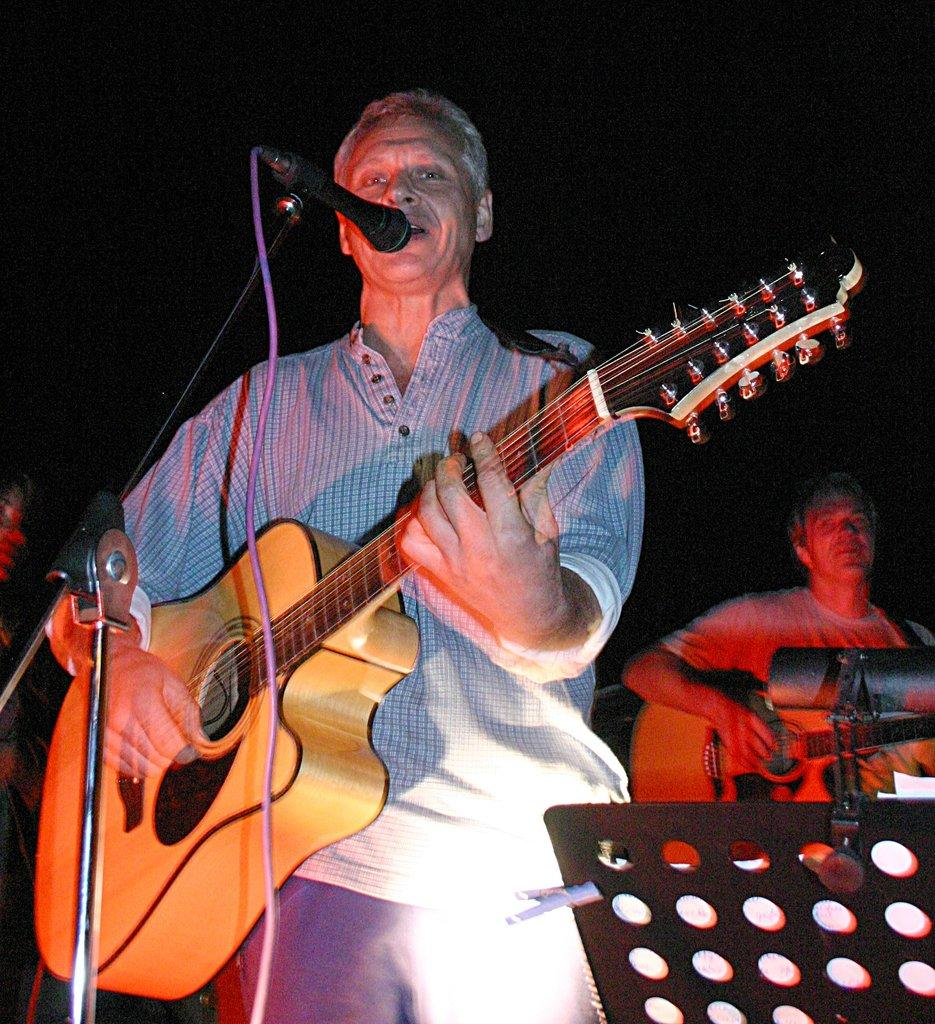What is the man in the image doing? The man is playing guitar and singing in the image. How is the man amplifying his voice? The man is using a microphone in the image. Is there anyone else in the image? Yes, there is another person in the image. What is the other person doing? The other person is playing guitar on his back in the image. What type of plantation can be seen in the background of the image? There is no plantation visible in the image; it features a man playing guitar, a microphone, and another person playing guitar on his back. 